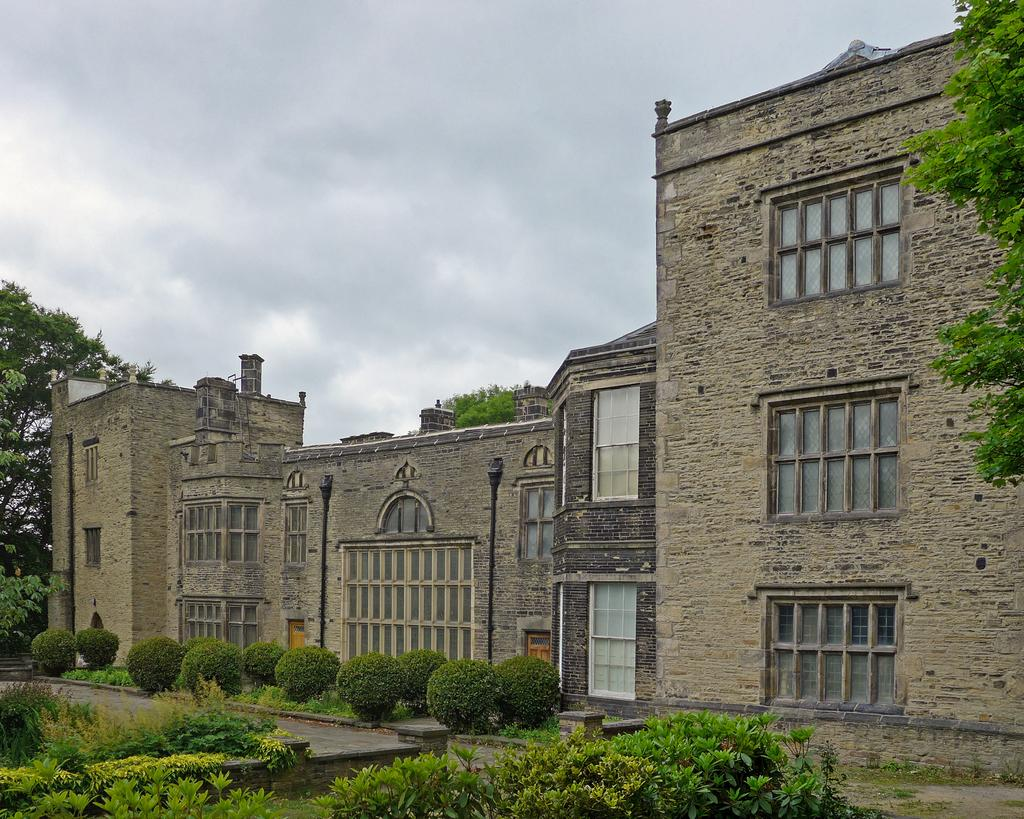What type of structure is present in the image? There is a building in the image. What feature can be seen on the building? The building has windows. What type of vegetation is visible in the image? There are plants and trees in the image. How many poles are present in the image? There are two poles in the image. What type of rice is being harvested in the field shown in the image? There is no field or rice present in the image; it features a building, plants, trees, and poles. 